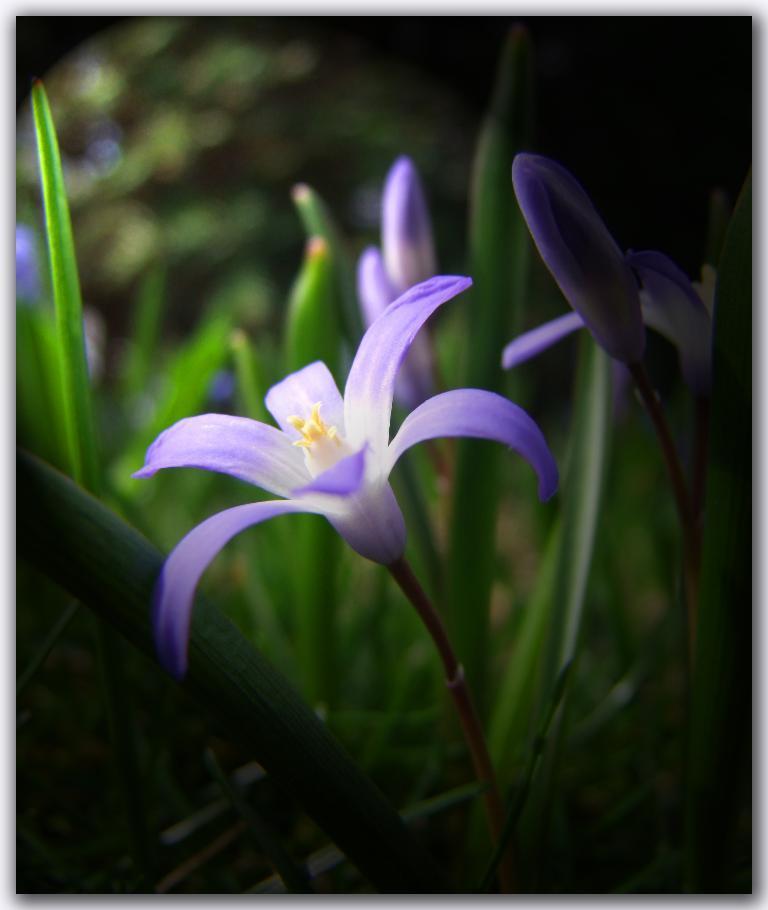Could you give a brief overview of what you see in this image? In this image we can see the flowers and flower buds, we can see the leaves. 